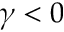<formula> <loc_0><loc_0><loc_500><loc_500>\gamma < 0</formula> 